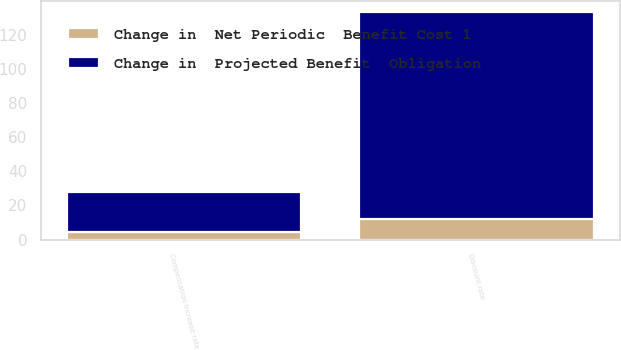Convert chart to OTSL. <chart><loc_0><loc_0><loc_500><loc_500><stacked_bar_chart><ecel><fcel>Discount rate<fcel>Compensation increase rate<nl><fcel>Change in  Projected Benefit  Obligation<fcel>121.1<fcel>23.4<nl><fcel>Change in  Net Periodic  Benefit Cost 1<fcel>12<fcel>4.7<nl></chart> 